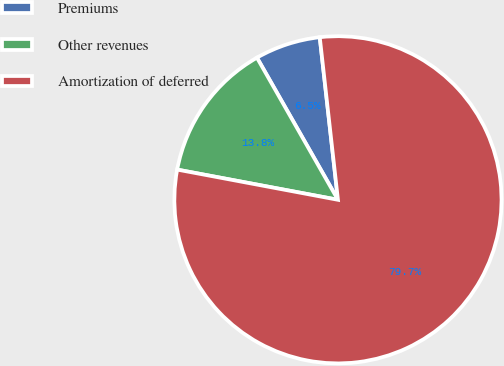Convert chart to OTSL. <chart><loc_0><loc_0><loc_500><loc_500><pie_chart><fcel>Premiums<fcel>Other revenues<fcel>Amortization of deferred<nl><fcel>6.47%<fcel>13.8%<fcel>79.73%<nl></chart> 